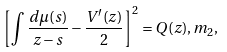<formula> <loc_0><loc_0><loc_500><loc_500>\left [ \int \frac { d \mu ( s ) } { z - s } - \frac { V ^ { \prime } ( z ) } { 2 } \right ] ^ { 2 } = Q ( z ) , m _ { 2 } ,</formula> 